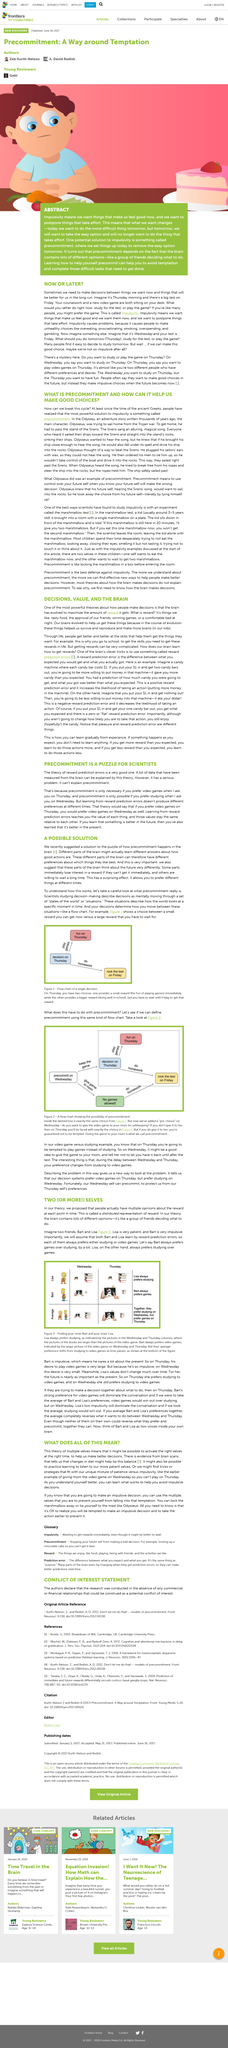Draw attention to some important aspects in this diagram. We recently suggested a solution to the puzzle of how precommitment happens in the brain, which is a definite solution. The boy in the picture is looking at a cake. The evolution of human brains is driven by a fundamental goal of maximizing the amount of reward they receive, as this has been shown to be critical to survival, reproduction, and the continuation of our species. The theory of multiple selves suggests that it is possible to activate the appropriate self at the appropriate time in order to make better decisions. The brain has evolved to maximize the amount of reward it receives. 